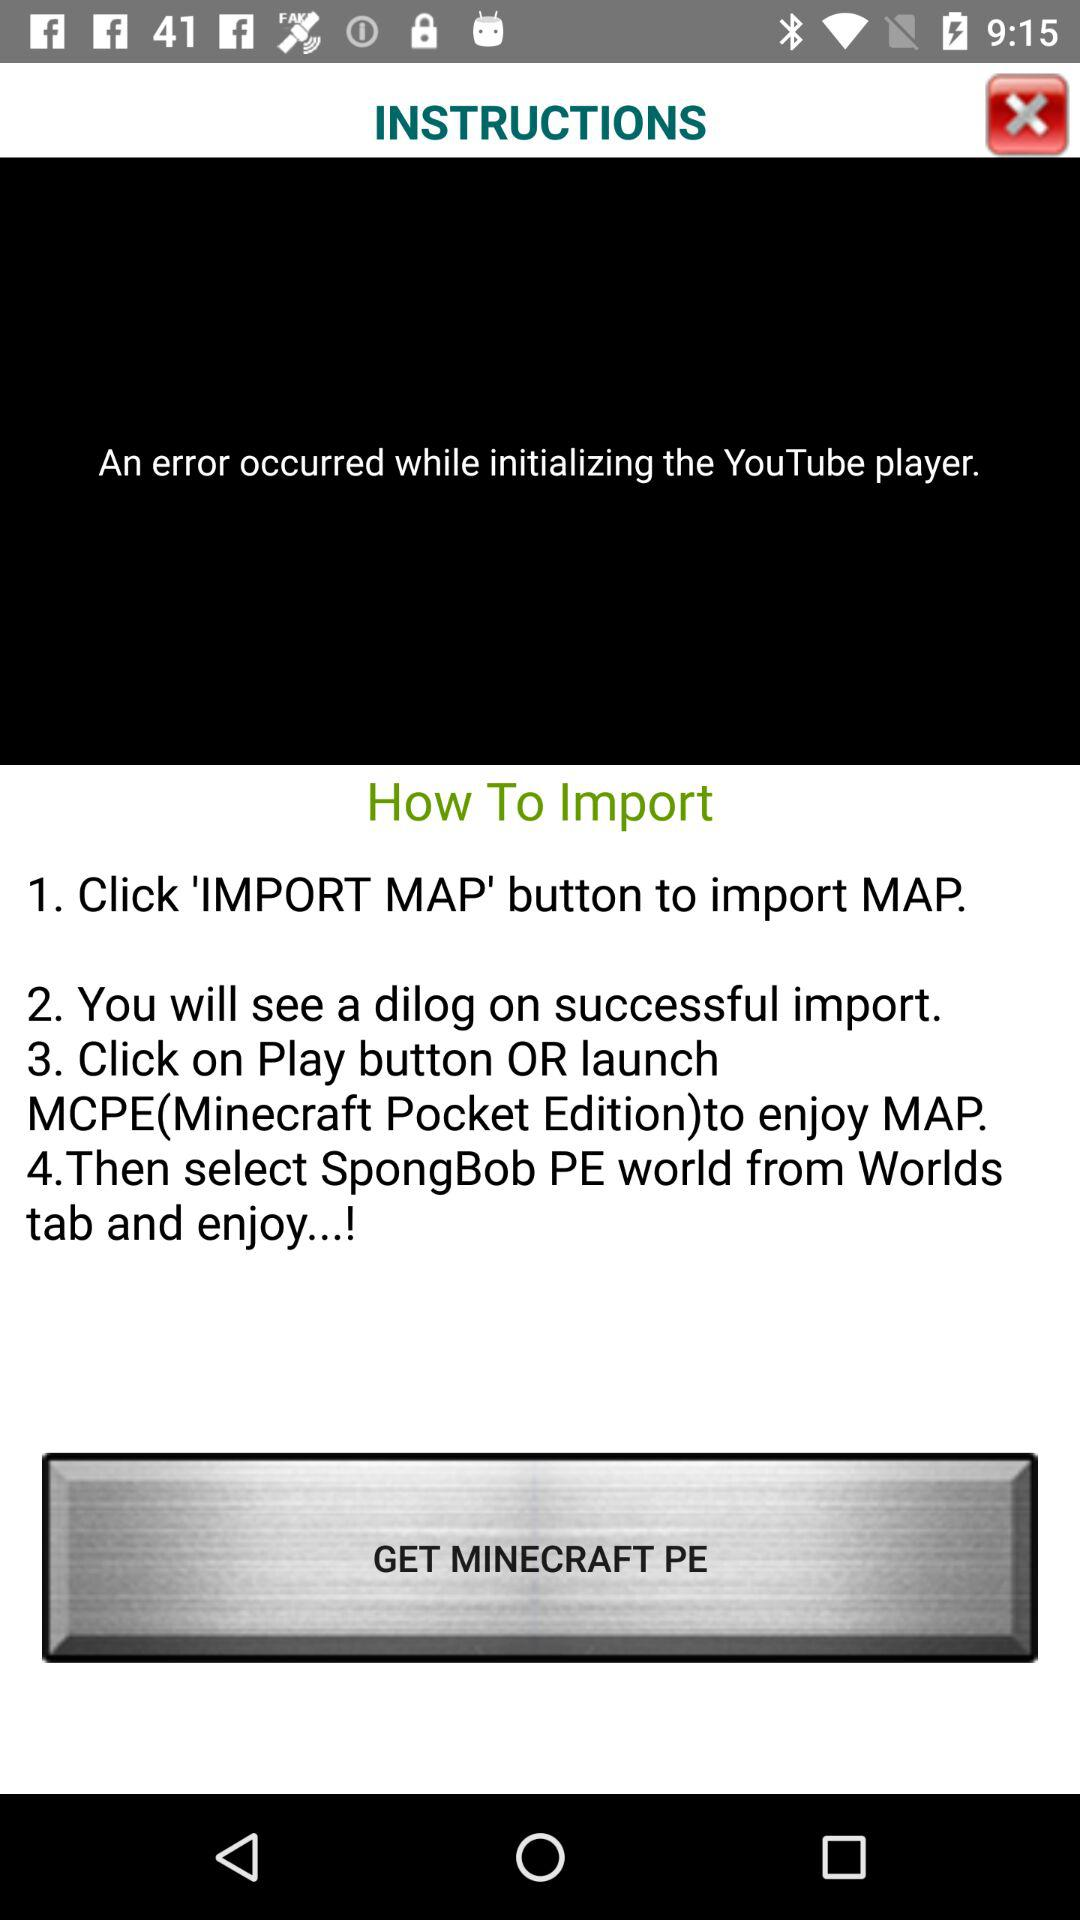How many steps are there in the instructions?
Answer the question using a single word or phrase. 4 